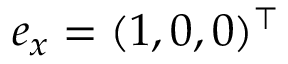Convert formula to latex. <formula><loc_0><loc_0><loc_500><loc_500>e _ { x } = ( 1 , 0 , 0 ) ^ { \top }</formula> 